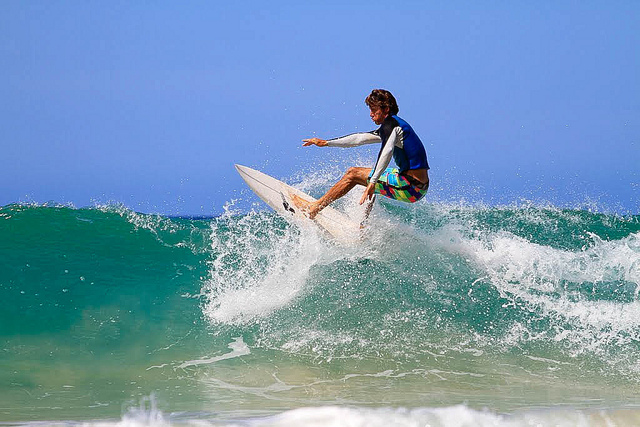<image>Who is the person on the board? I don't know who the person on the board is. However, it could be a surfer or a man. Who is the person on the board? I am unsure who the person on the board is. It could be a man or a surfer. 